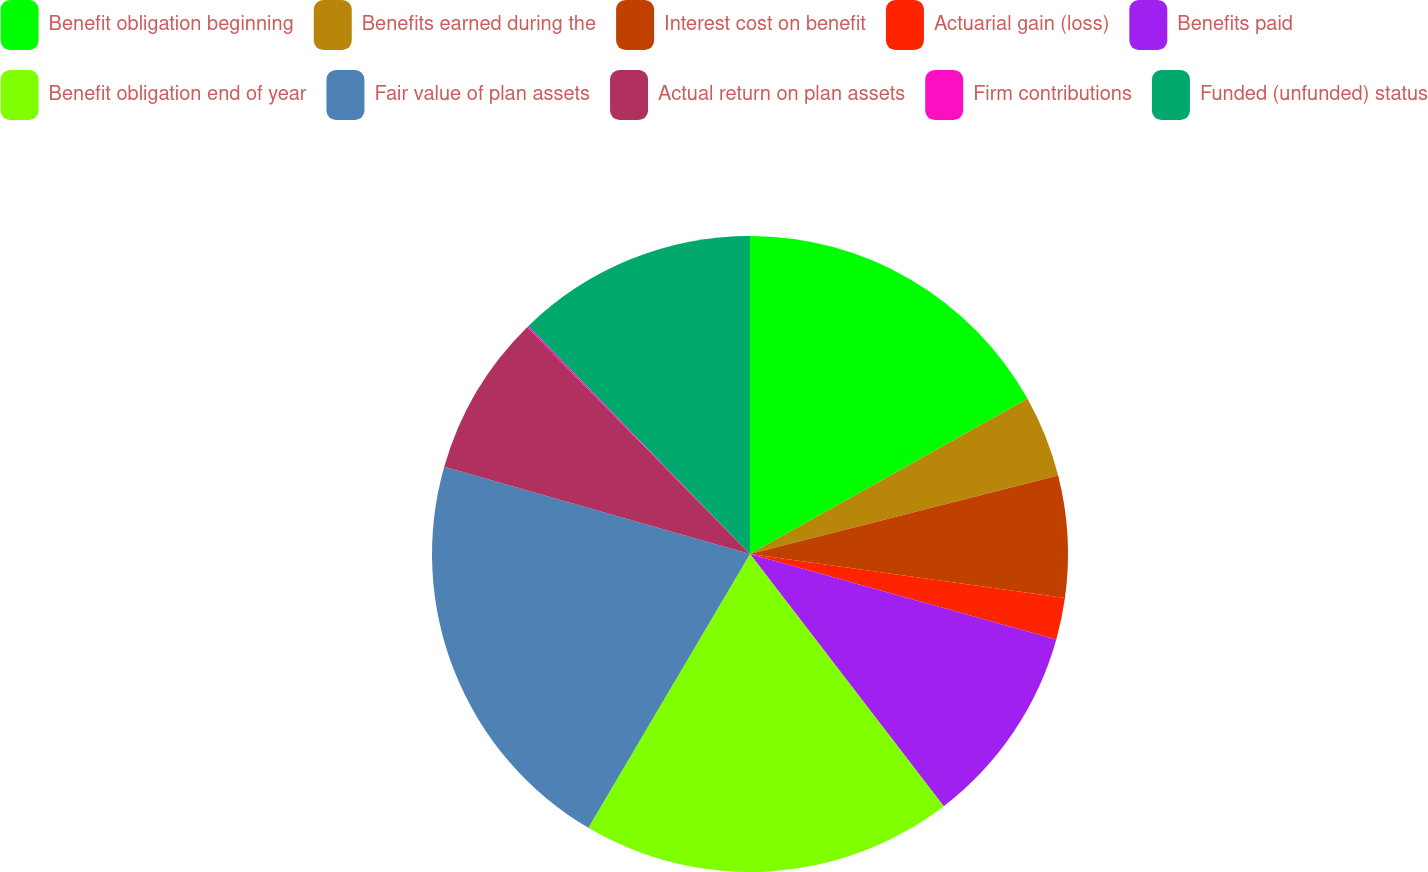Convert chart to OTSL. <chart><loc_0><loc_0><loc_500><loc_500><pie_chart><fcel>Benefit obligation beginning<fcel>Benefits earned during the<fcel>Interest cost on benefit<fcel>Actuarial gain (loss)<fcel>Benefits paid<fcel>Benefit obligation end of year<fcel>Fair value of plan assets<fcel>Actual return on plan assets<fcel>Firm contributions<fcel>Funded (unfunded) status<nl><fcel>16.88%<fcel>4.15%<fcel>6.18%<fcel>2.12%<fcel>10.24%<fcel>18.91%<fcel>20.94%<fcel>8.21%<fcel>0.09%<fcel>12.27%<nl></chart> 